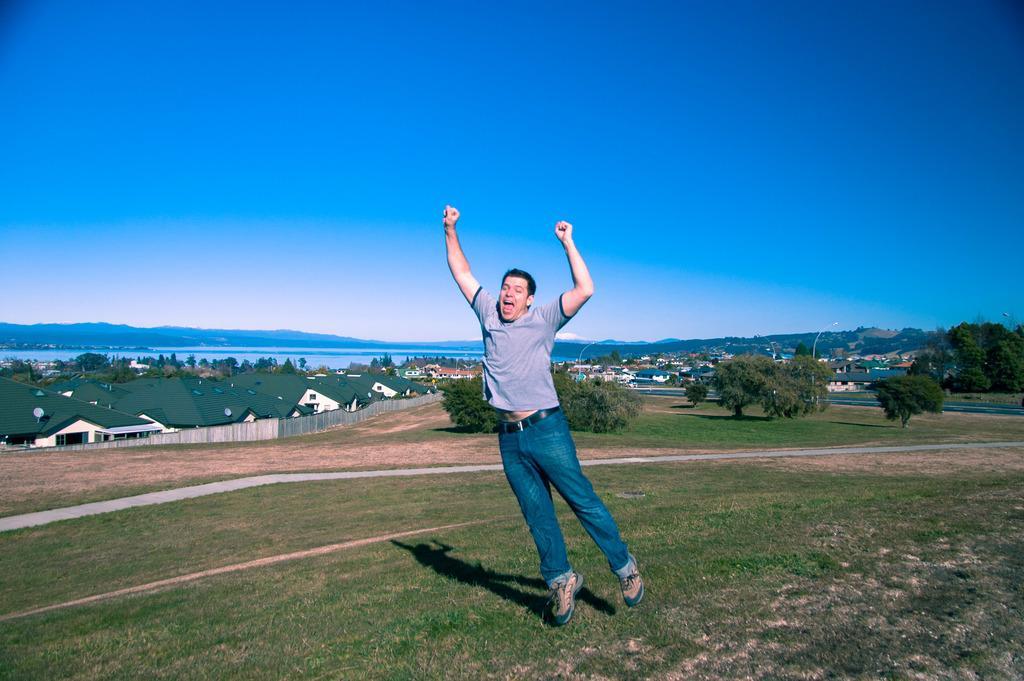Please provide a concise description of this image. In this picture I can see a man jumping and I can see buildings, trees and water and I can see grass on the ground and a blue sky. 